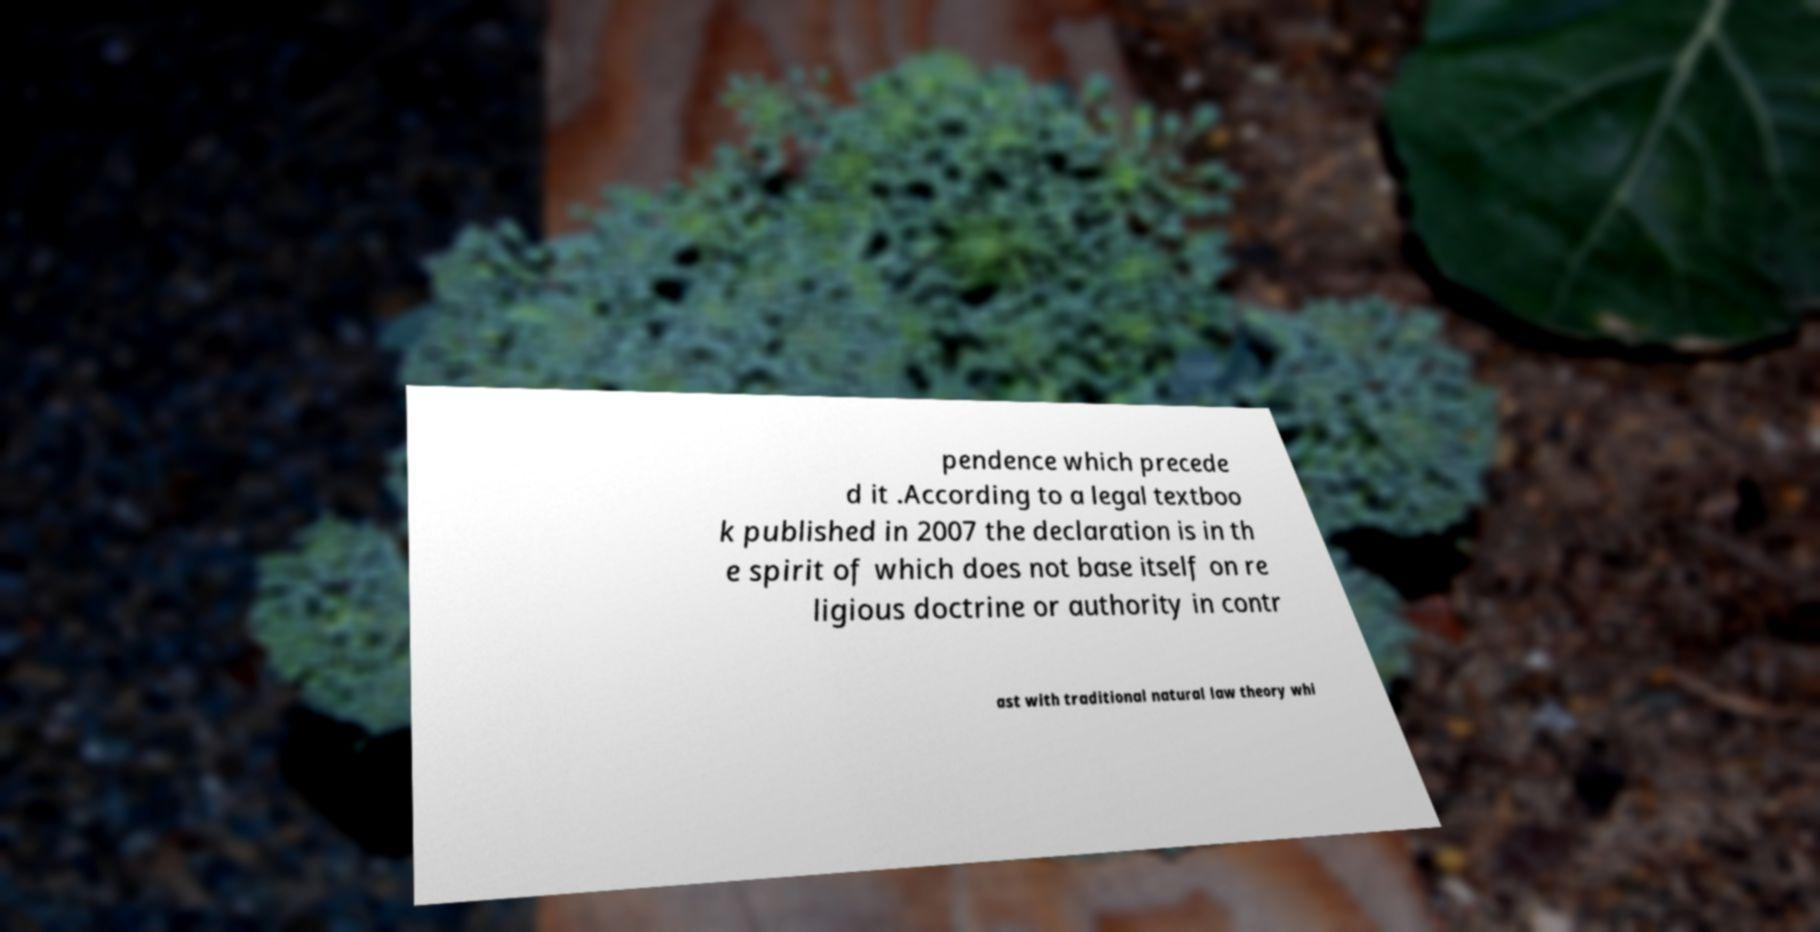I need the written content from this picture converted into text. Can you do that? pendence which precede d it .According to a legal textboo k published in 2007 the declaration is in th e spirit of which does not base itself on re ligious doctrine or authority in contr ast with traditional natural law theory whi 